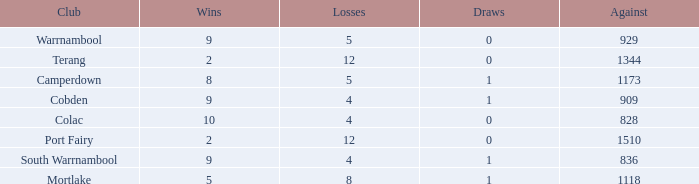What is the total number of Against values for clubs with more than 2 wins, 5 losses, and 0 draws? 0.0. 